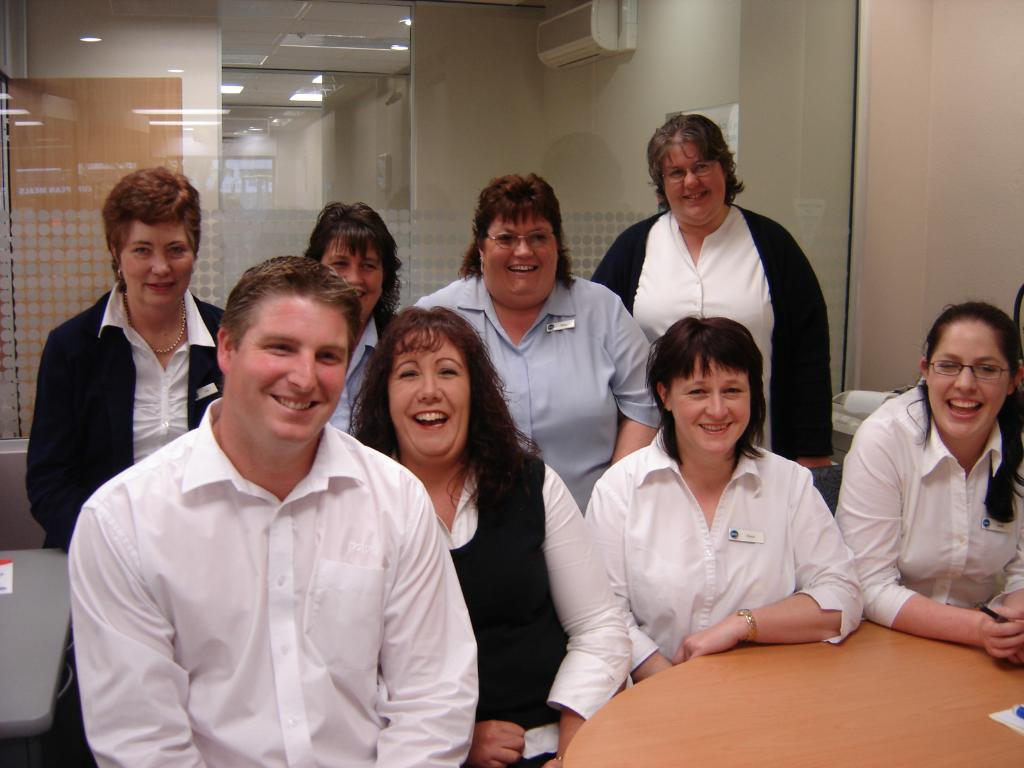What are the people in the image wearing? The persons in the image are wearing clothes. Can you describe the furniture or objects in the image? There is a table in the bottom right of the image. What appliance is visible at the top of the image? There is an air conditioner at the top of the image. How many boxes can be seen stacked on the truck in the image? There is no truck or boxes present in the image. Is there a deer visible in the image? No, there is no deer present in the image. 